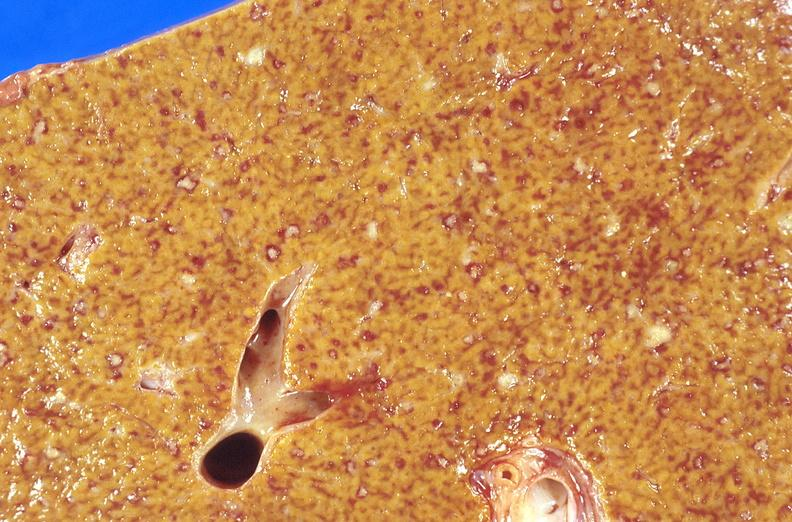s hepatobiliary present?
Answer the question using a single word or phrase. Yes 